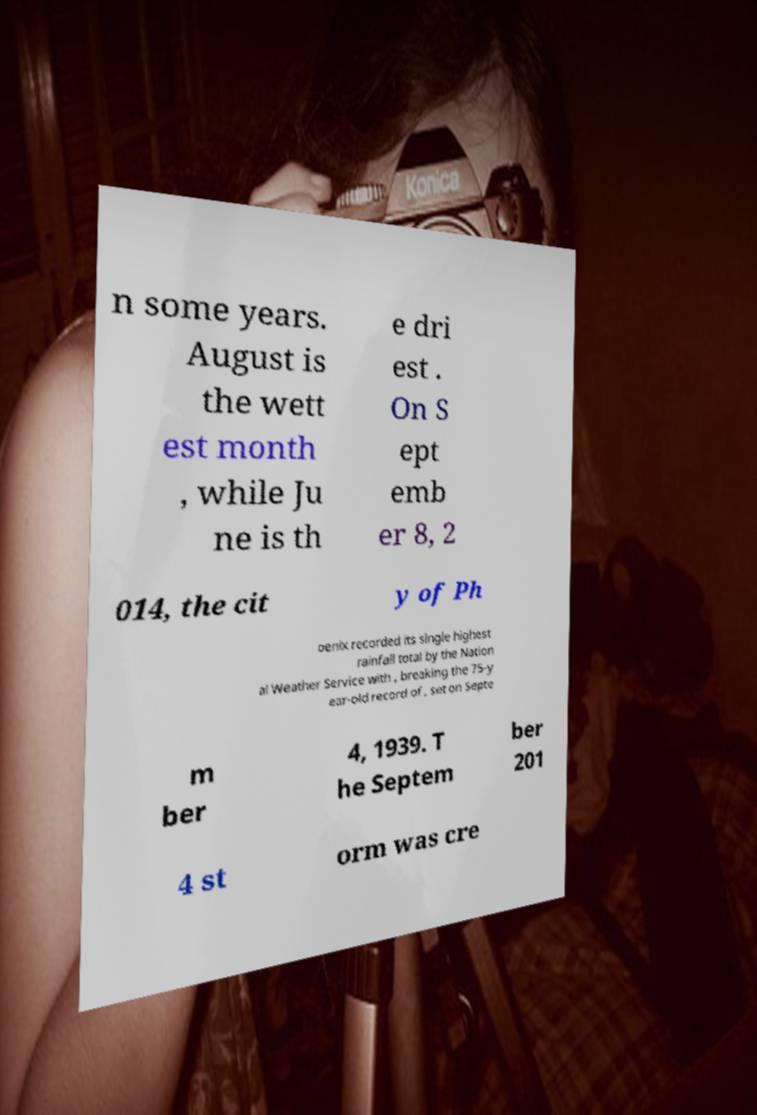Could you extract and type out the text from this image? n some years. August is the wett est month , while Ju ne is th e dri est . On S ept emb er 8, 2 014, the cit y of Ph oenix recorded its single highest rainfall total by the Nation al Weather Service with , breaking the 75-y ear-old record of , set on Septe m ber 4, 1939. T he Septem ber 201 4 st orm was cre 